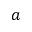<formula> <loc_0><loc_0><loc_500><loc_500>a</formula> 